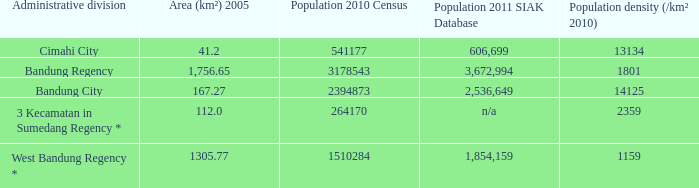What is the population density of bandung regency? 1801.0. 